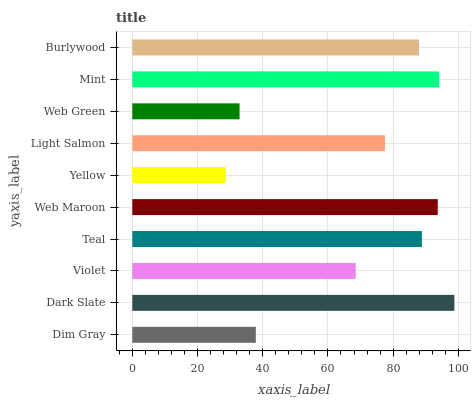Is Yellow the minimum?
Answer yes or no. Yes. Is Dark Slate the maximum?
Answer yes or no. Yes. Is Violet the minimum?
Answer yes or no. No. Is Violet the maximum?
Answer yes or no. No. Is Dark Slate greater than Violet?
Answer yes or no. Yes. Is Violet less than Dark Slate?
Answer yes or no. Yes. Is Violet greater than Dark Slate?
Answer yes or no. No. Is Dark Slate less than Violet?
Answer yes or no. No. Is Burlywood the high median?
Answer yes or no. Yes. Is Light Salmon the low median?
Answer yes or no. Yes. Is Dark Slate the high median?
Answer yes or no. No. Is Teal the low median?
Answer yes or no. No. 